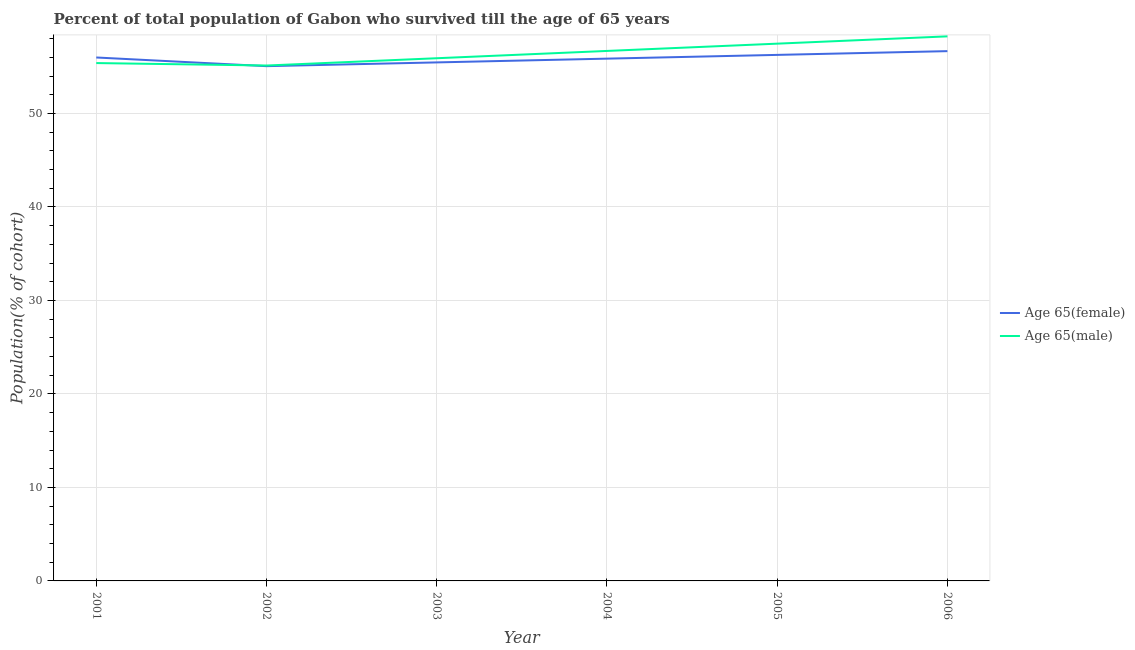How many different coloured lines are there?
Provide a succinct answer. 2. What is the percentage of female population who survived till age of 65 in 2004?
Provide a short and direct response. 55.86. Across all years, what is the maximum percentage of female population who survived till age of 65?
Keep it short and to the point. 56.66. Across all years, what is the minimum percentage of female population who survived till age of 65?
Provide a succinct answer. 55.06. What is the total percentage of male population who survived till age of 65 in the graph?
Offer a terse response. 338.81. What is the difference between the percentage of male population who survived till age of 65 in 2003 and that in 2005?
Your answer should be very brief. -1.56. What is the difference between the percentage of female population who survived till age of 65 in 2004 and the percentage of male population who survived till age of 65 in 2005?
Offer a very short reply. -1.6. What is the average percentage of female population who survived till age of 65 per year?
Your response must be concise. 55.88. In the year 2004, what is the difference between the percentage of female population who survived till age of 65 and percentage of male population who survived till age of 65?
Ensure brevity in your answer.  -0.82. In how many years, is the percentage of male population who survived till age of 65 greater than 56 %?
Provide a short and direct response. 3. What is the ratio of the percentage of male population who survived till age of 65 in 2003 to that in 2004?
Provide a short and direct response. 0.99. Is the difference between the percentage of female population who survived till age of 65 in 2002 and 2006 greater than the difference between the percentage of male population who survived till age of 65 in 2002 and 2006?
Keep it short and to the point. Yes. What is the difference between the highest and the second highest percentage of female population who survived till age of 65?
Ensure brevity in your answer.  0.4. What is the difference between the highest and the lowest percentage of female population who survived till age of 65?
Your response must be concise. 1.61. Is the sum of the percentage of male population who survived till age of 65 in 2003 and 2004 greater than the maximum percentage of female population who survived till age of 65 across all years?
Offer a very short reply. Yes. Does the graph contain any zero values?
Give a very brief answer. No. Does the graph contain grids?
Make the answer very short. Yes. Where does the legend appear in the graph?
Provide a succinct answer. Center right. How many legend labels are there?
Keep it short and to the point. 2. How are the legend labels stacked?
Keep it short and to the point. Vertical. What is the title of the graph?
Your answer should be very brief. Percent of total population of Gabon who survived till the age of 65 years. Does "Secondary education" appear as one of the legend labels in the graph?
Keep it short and to the point. No. What is the label or title of the Y-axis?
Give a very brief answer. Population(% of cohort). What is the Population(% of cohort) in Age 65(female) in 2001?
Offer a terse response. 55.98. What is the Population(% of cohort) in Age 65(male) in 2001?
Your response must be concise. 55.39. What is the Population(% of cohort) of Age 65(female) in 2002?
Keep it short and to the point. 55.06. What is the Population(% of cohort) of Age 65(male) in 2002?
Give a very brief answer. 55.13. What is the Population(% of cohort) of Age 65(female) in 2003?
Offer a terse response. 55.46. What is the Population(% of cohort) in Age 65(male) in 2003?
Provide a succinct answer. 55.91. What is the Population(% of cohort) in Age 65(female) in 2004?
Keep it short and to the point. 55.86. What is the Population(% of cohort) of Age 65(male) in 2004?
Ensure brevity in your answer.  56.68. What is the Population(% of cohort) of Age 65(female) in 2005?
Provide a succinct answer. 56.26. What is the Population(% of cohort) of Age 65(male) in 2005?
Provide a succinct answer. 57.46. What is the Population(% of cohort) of Age 65(female) in 2006?
Provide a succinct answer. 56.66. What is the Population(% of cohort) of Age 65(male) in 2006?
Your answer should be very brief. 58.24. Across all years, what is the maximum Population(% of cohort) of Age 65(female)?
Your answer should be very brief. 56.66. Across all years, what is the maximum Population(% of cohort) in Age 65(male)?
Give a very brief answer. 58.24. Across all years, what is the minimum Population(% of cohort) in Age 65(female)?
Give a very brief answer. 55.06. Across all years, what is the minimum Population(% of cohort) of Age 65(male)?
Offer a very short reply. 55.13. What is the total Population(% of cohort) in Age 65(female) in the graph?
Give a very brief answer. 335.29. What is the total Population(% of cohort) in Age 65(male) in the graph?
Offer a terse response. 338.81. What is the difference between the Population(% of cohort) in Age 65(female) in 2001 and that in 2002?
Your response must be concise. 0.93. What is the difference between the Population(% of cohort) of Age 65(male) in 2001 and that in 2002?
Offer a terse response. 0.26. What is the difference between the Population(% of cohort) in Age 65(female) in 2001 and that in 2003?
Your answer should be compact. 0.53. What is the difference between the Population(% of cohort) of Age 65(male) in 2001 and that in 2003?
Make the answer very short. -0.52. What is the difference between the Population(% of cohort) of Age 65(female) in 2001 and that in 2004?
Offer a terse response. 0.12. What is the difference between the Population(% of cohort) of Age 65(male) in 2001 and that in 2004?
Offer a terse response. -1.3. What is the difference between the Population(% of cohort) in Age 65(female) in 2001 and that in 2005?
Your answer should be compact. -0.28. What is the difference between the Population(% of cohort) in Age 65(male) in 2001 and that in 2005?
Your response must be concise. -2.08. What is the difference between the Population(% of cohort) of Age 65(female) in 2001 and that in 2006?
Your answer should be compact. -0.68. What is the difference between the Population(% of cohort) of Age 65(male) in 2001 and that in 2006?
Offer a terse response. -2.86. What is the difference between the Population(% of cohort) in Age 65(female) in 2002 and that in 2003?
Give a very brief answer. -0.4. What is the difference between the Population(% of cohort) of Age 65(male) in 2002 and that in 2003?
Give a very brief answer. -0.78. What is the difference between the Population(% of cohort) in Age 65(female) in 2002 and that in 2004?
Give a very brief answer. -0.8. What is the difference between the Population(% of cohort) in Age 65(male) in 2002 and that in 2004?
Provide a short and direct response. -1.56. What is the difference between the Population(% of cohort) in Age 65(female) in 2002 and that in 2005?
Ensure brevity in your answer.  -1.21. What is the difference between the Population(% of cohort) in Age 65(male) in 2002 and that in 2005?
Make the answer very short. -2.34. What is the difference between the Population(% of cohort) in Age 65(female) in 2002 and that in 2006?
Offer a very short reply. -1.61. What is the difference between the Population(% of cohort) in Age 65(male) in 2002 and that in 2006?
Make the answer very short. -3.12. What is the difference between the Population(% of cohort) of Age 65(female) in 2003 and that in 2004?
Offer a very short reply. -0.4. What is the difference between the Population(% of cohort) of Age 65(male) in 2003 and that in 2004?
Provide a succinct answer. -0.78. What is the difference between the Population(% of cohort) of Age 65(female) in 2003 and that in 2005?
Your answer should be very brief. -0.8. What is the difference between the Population(% of cohort) in Age 65(male) in 2003 and that in 2005?
Provide a succinct answer. -1.56. What is the difference between the Population(% of cohort) of Age 65(female) in 2003 and that in 2006?
Provide a short and direct response. -1.21. What is the difference between the Population(% of cohort) in Age 65(male) in 2003 and that in 2006?
Give a very brief answer. -2.34. What is the difference between the Population(% of cohort) in Age 65(female) in 2004 and that in 2005?
Make the answer very short. -0.4. What is the difference between the Population(% of cohort) of Age 65(male) in 2004 and that in 2005?
Offer a terse response. -0.78. What is the difference between the Population(% of cohort) of Age 65(female) in 2004 and that in 2006?
Provide a succinct answer. -0.8. What is the difference between the Population(% of cohort) of Age 65(male) in 2004 and that in 2006?
Keep it short and to the point. -1.56. What is the difference between the Population(% of cohort) of Age 65(female) in 2005 and that in 2006?
Give a very brief answer. -0.4. What is the difference between the Population(% of cohort) of Age 65(male) in 2005 and that in 2006?
Offer a terse response. -0.78. What is the difference between the Population(% of cohort) of Age 65(female) in 2001 and the Population(% of cohort) of Age 65(male) in 2002?
Provide a short and direct response. 0.86. What is the difference between the Population(% of cohort) of Age 65(female) in 2001 and the Population(% of cohort) of Age 65(male) in 2003?
Your response must be concise. 0.08. What is the difference between the Population(% of cohort) in Age 65(female) in 2001 and the Population(% of cohort) in Age 65(male) in 2004?
Give a very brief answer. -0.7. What is the difference between the Population(% of cohort) in Age 65(female) in 2001 and the Population(% of cohort) in Age 65(male) in 2005?
Offer a terse response. -1.48. What is the difference between the Population(% of cohort) of Age 65(female) in 2001 and the Population(% of cohort) of Age 65(male) in 2006?
Your response must be concise. -2.26. What is the difference between the Population(% of cohort) in Age 65(female) in 2002 and the Population(% of cohort) in Age 65(male) in 2003?
Offer a very short reply. -0.85. What is the difference between the Population(% of cohort) in Age 65(female) in 2002 and the Population(% of cohort) in Age 65(male) in 2004?
Your answer should be compact. -1.63. What is the difference between the Population(% of cohort) in Age 65(female) in 2002 and the Population(% of cohort) in Age 65(male) in 2005?
Keep it short and to the point. -2.41. What is the difference between the Population(% of cohort) in Age 65(female) in 2002 and the Population(% of cohort) in Age 65(male) in 2006?
Keep it short and to the point. -3.19. What is the difference between the Population(% of cohort) in Age 65(female) in 2003 and the Population(% of cohort) in Age 65(male) in 2004?
Ensure brevity in your answer.  -1.23. What is the difference between the Population(% of cohort) of Age 65(female) in 2003 and the Population(% of cohort) of Age 65(male) in 2005?
Ensure brevity in your answer.  -2.01. What is the difference between the Population(% of cohort) of Age 65(female) in 2003 and the Population(% of cohort) of Age 65(male) in 2006?
Ensure brevity in your answer.  -2.79. What is the difference between the Population(% of cohort) of Age 65(female) in 2004 and the Population(% of cohort) of Age 65(male) in 2005?
Your answer should be compact. -1.6. What is the difference between the Population(% of cohort) in Age 65(female) in 2004 and the Population(% of cohort) in Age 65(male) in 2006?
Your response must be concise. -2.38. What is the difference between the Population(% of cohort) in Age 65(female) in 2005 and the Population(% of cohort) in Age 65(male) in 2006?
Keep it short and to the point. -1.98. What is the average Population(% of cohort) of Age 65(female) per year?
Keep it short and to the point. 55.88. What is the average Population(% of cohort) in Age 65(male) per year?
Your answer should be very brief. 56.47. In the year 2001, what is the difference between the Population(% of cohort) of Age 65(female) and Population(% of cohort) of Age 65(male)?
Provide a short and direct response. 0.6. In the year 2002, what is the difference between the Population(% of cohort) in Age 65(female) and Population(% of cohort) in Age 65(male)?
Your response must be concise. -0.07. In the year 2003, what is the difference between the Population(% of cohort) in Age 65(female) and Population(% of cohort) in Age 65(male)?
Keep it short and to the point. -0.45. In the year 2004, what is the difference between the Population(% of cohort) in Age 65(female) and Population(% of cohort) in Age 65(male)?
Provide a succinct answer. -0.82. In the year 2005, what is the difference between the Population(% of cohort) in Age 65(female) and Population(% of cohort) in Age 65(male)?
Provide a succinct answer. -1.2. In the year 2006, what is the difference between the Population(% of cohort) in Age 65(female) and Population(% of cohort) in Age 65(male)?
Your answer should be very brief. -1.58. What is the ratio of the Population(% of cohort) of Age 65(female) in 2001 to that in 2002?
Your answer should be very brief. 1.02. What is the ratio of the Population(% of cohort) of Age 65(female) in 2001 to that in 2003?
Give a very brief answer. 1.01. What is the ratio of the Population(% of cohort) in Age 65(female) in 2001 to that in 2004?
Your answer should be compact. 1. What is the ratio of the Population(% of cohort) in Age 65(male) in 2001 to that in 2004?
Ensure brevity in your answer.  0.98. What is the ratio of the Population(% of cohort) of Age 65(female) in 2001 to that in 2005?
Offer a very short reply. 1. What is the ratio of the Population(% of cohort) in Age 65(male) in 2001 to that in 2005?
Make the answer very short. 0.96. What is the ratio of the Population(% of cohort) of Age 65(male) in 2001 to that in 2006?
Offer a terse response. 0.95. What is the ratio of the Population(% of cohort) in Age 65(male) in 2002 to that in 2003?
Give a very brief answer. 0.99. What is the ratio of the Population(% of cohort) of Age 65(female) in 2002 to that in 2004?
Provide a succinct answer. 0.99. What is the ratio of the Population(% of cohort) of Age 65(male) in 2002 to that in 2004?
Your answer should be very brief. 0.97. What is the ratio of the Population(% of cohort) in Age 65(female) in 2002 to that in 2005?
Provide a short and direct response. 0.98. What is the ratio of the Population(% of cohort) of Age 65(male) in 2002 to that in 2005?
Provide a short and direct response. 0.96. What is the ratio of the Population(% of cohort) of Age 65(female) in 2002 to that in 2006?
Offer a terse response. 0.97. What is the ratio of the Population(% of cohort) of Age 65(male) in 2002 to that in 2006?
Provide a short and direct response. 0.95. What is the ratio of the Population(% of cohort) of Age 65(male) in 2003 to that in 2004?
Offer a very short reply. 0.99. What is the ratio of the Population(% of cohort) of Age 65(female) in 2003 to that in 2005?
Keep it short and to the point. 0.99. What is the ratio of the Population(% of cohort) of Age 65(male) in 2003 to that in 2005?
Your answer should be very brief. 0.97. What is the ratio of the Population(% of cohort) in Age 65(female) in 2003 to that in 2006?
Provide a short and direct response. 0.98. What is the ratio of the Population(% of cohort) in Age 65(male) in 2003 to that in 2006?
Your response must be concise. 0.96. What is the ratio of the Population(% of cohort) in Age 65(male) in 2004 to that in 2005?
Keep it short and to the point. 0.99. What is the ratio of the Population(% of cohort) of Age 65(female) in 2004 to that in 2006?
Provide a short and direct response. 0.99. What is the ratio of the Population(% of cohort) of Age 65(male) in 2004 to that in 2006?
Ensure brevity in your answer.  0.97. What is the ratio of the Population(% of cohort) in Age 65(male) in 2005 to that in 2006?
Offer a very short reply. 0.99. What is the difference between the highest and the second highest Population(% of cohort) in Age 65(female)?
Give a very brief answer. 0.4. What is the difference between the highest and the second highest Population(% of cohort) in Age 65(male)?
Your answer should be very brief. 0.78. What is the difference between the highest and the lowest Population(% of cohort) of Age 65(female)?
Your response must be concise. 1.61. What is the difference between the highest and the lowest Population(% of cohort) of Age 65(male)?
Your response must be concise. 3.12. 